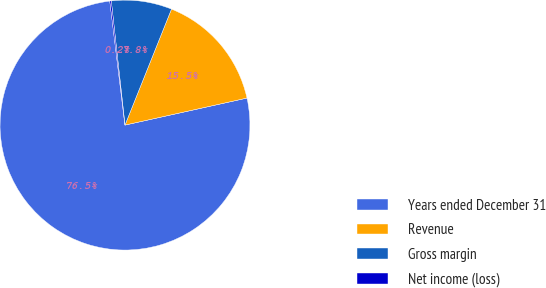Convert chart. <chart><loc_0><loc_0><loc_500><loc_500><pie_chart><fcel>Years ended December 31<fcel>Revenue<fcel>Gross margin<fcel>Net income (loss)<nl><fcel>76.53%<fcel>15.46%<fcel>7.82%<fcel>0.19%<nl></chart> 